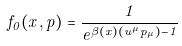<formula> <loc_0><loc_0><loc_500><loc_500>f _ { 0 } ( x , p ) = \frac { 1 } { e ^ { \beta ( x ) ( u ^ { \mu } p _ { \mu } ) - 1 } }</formula> 